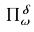<formula> <loc_0><loc_0><loc_500><loc_500>\Pi _ { \omega } ^ { \delta }</formula> 